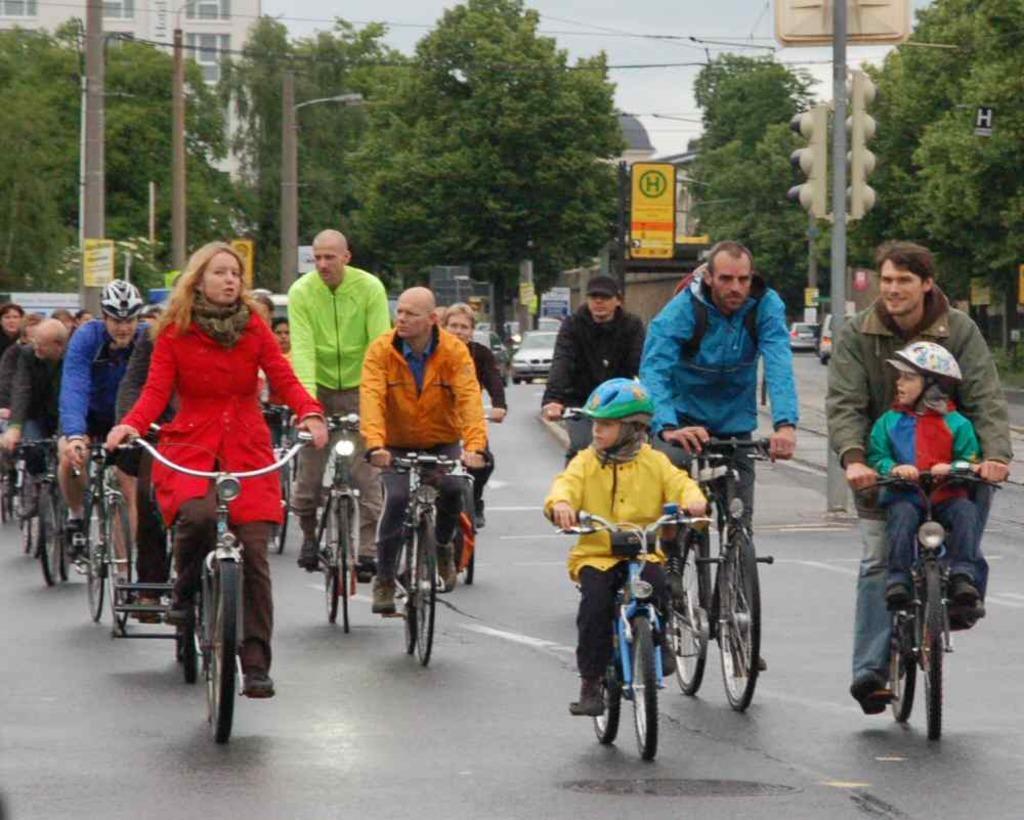Could you give a brief overview of what you see in this image? The picture consists of many people riding bicycle on road,it seems to be on a street and there are trees in the background and a traffic pole on the left corner and some cars coming on the road. There is a building on the total background. 